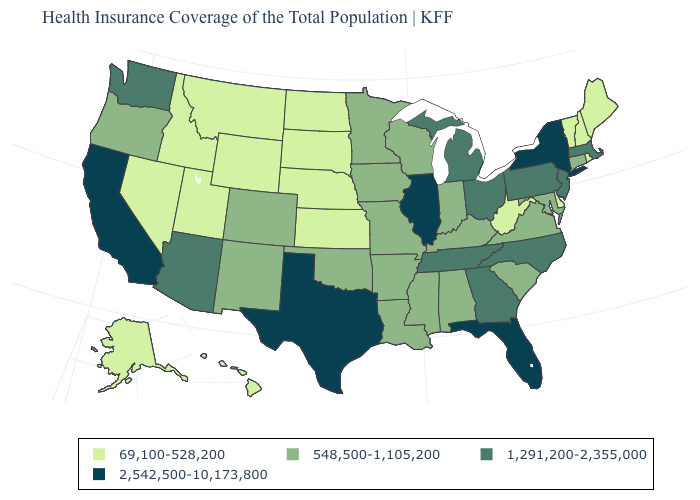Among the states that border Washington , which have the lowest value?
Give a very brief answer. Idaho. What is the value of Tennessee?
Short answer required. 1,291,200-2,355,000. Which states have the lowest value in the South?
Write a very short answer. Delaware, West Virginia. What is the value of Iowa?
Answer briefly. 548,500-1,105,200. What is the lowest value in states that border Arizona?
Give a very brief answer. 69,100-528,200. Does Kansas have the highest value in the MidWest?
Answer briefly. No. Among the states that border Iowa , does Illinois have the highest value?
Write a very short answer. Yes. Name the states that have a value in the range 1,291,200-2,355,000?
Concise answer only. Arizona, Georgia, Massachusetts, Michigan, New Jersey, North Carolina, Ohio, Pennsylvania, Tennessee, Washington. Does Colorado have a lower value than Alabama?
Keep it brief. No. Name the states that have a value in the range 69,100-528,200?
Concise answer only. Alaska, Delaware, Hawaii, Idaho, Kansas, Maine, Montana, Nebraska, Nevada, New Hampshire, North Dakota, Rhode Island, South Dakota, Utah, Vermont, West Virginia, Wyoming. Which states have the lowest value in the USA?
Answer briefly. Alaska, Delaware, Hawaii, Idaho, Kansas, Maine, Montana, Nebraska, Nevada, New Hampshire, North Dakota, Rhode Island, South Dakota, Utah, Vermont, West Virginia, Wyoming. What is the value of Louisiana?
Concise answer only. 548,500-1,105,200. What is the value of Georgia?
Answer briefly. 1,291,200-2,355,000. Name the states that have a value in the range 1,291,200-2,355,000?
Answer briefly. Arizona, Georgia, Massachusetts, Michigan, New Jersey, North Carolina, Ohio, Pennsylvania, Tennessee, Washington. What is the lowest value in the MidWest?
Answer briefly. 69,100-528,200. 